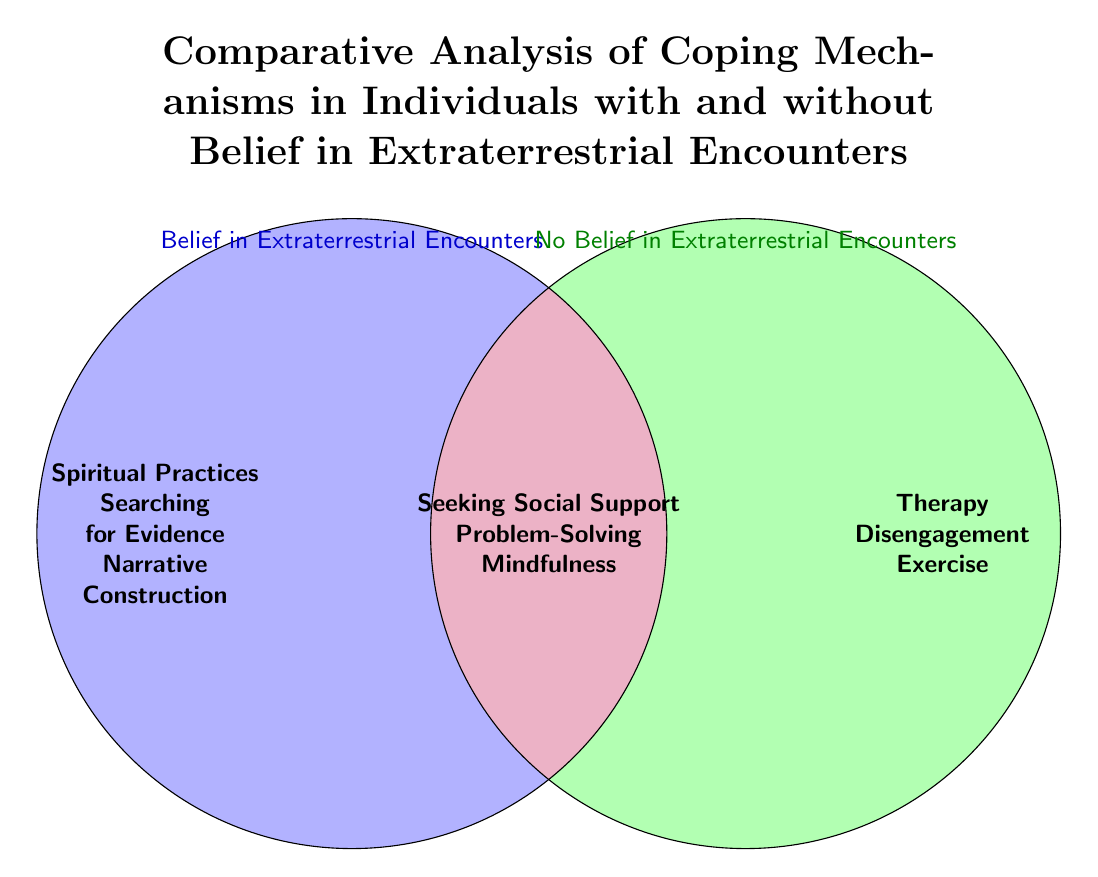What are the coping mechanisms for individuals with belief in extraterrestrial encounters? The left circle indicates the coping mechanisms for individuals with belief in extraterrestrial encounters. These mechanisms listed include "Spiritual Practices," "Searching for Evidence," and "Narrative Construction."
Answer: Spiritual Practices, Searching for Evidence, Narrative Construction What are the coping mechanisms for individuals without belief in extraterrestrial encounters? The right circle indicates the coping mechanisms for individuals without belief in extraterrestrial encounters. These mechanisms listed include "Therapy," "Disengagement," and "Exercise."
Answer: Therapy, Disengagement, Exercise What coping mechanisms are common to both groups? The overlapping area of the two circles represents coping mechanisms common to both individuals with and without belief in extraterrestrial encounters. These mechanisms listed include "Seeking Social Support," "Problem-Solving," and "Mindfulness."
Answer: Seeking Social Support, Problem-Solving, Mindfulness How many coping mechanisms are exclusive to the belief group? The left circle contains three unique coping mechanisms: "Spiritual Practices," "Searching for Evidence," and "Narrative Construction." Therefore, the count of exclusive mechanisms is three.
Answer: 3 Which coping mechanism appears in the common area? The overlapping space at the center shows coping mechanisms that both groups utilize. Among them, "Seeking Social Support" is explicitly mentioned.
Answer: Seeking Social Support How many total coping mechanisms are represented in the diagram? We can count the unique mechanisms in both circles and the common area: 3 (belief) + 3 (no belief) + 3 (common) = 9. Thus, the total number of coping mechanisms is nine.
Answer: 9 Which mechanism is listed as first for individuals without belief? The first mechanism listed in the right circle (individuals with no belief) is "Therapy."
Answer: Therapy What do the colored areas in the diagram represent? The left blue area represents coping mechanisms for individuals with belief, the right green area for those without belief, and the purple area in the center shows common coping mechanisms for both groups.
Answer: Coping mechanisms for belief, no belief, and common mechanisms Which group includes narrative construction as a coping mechanism? "Narrative Construction" is placed within the left circle, indicating it is a coping mechanism specifically for individuals who believe in extraterrestrial encounters.
Answer: Individuals with belief in extraterrestrial encounters 